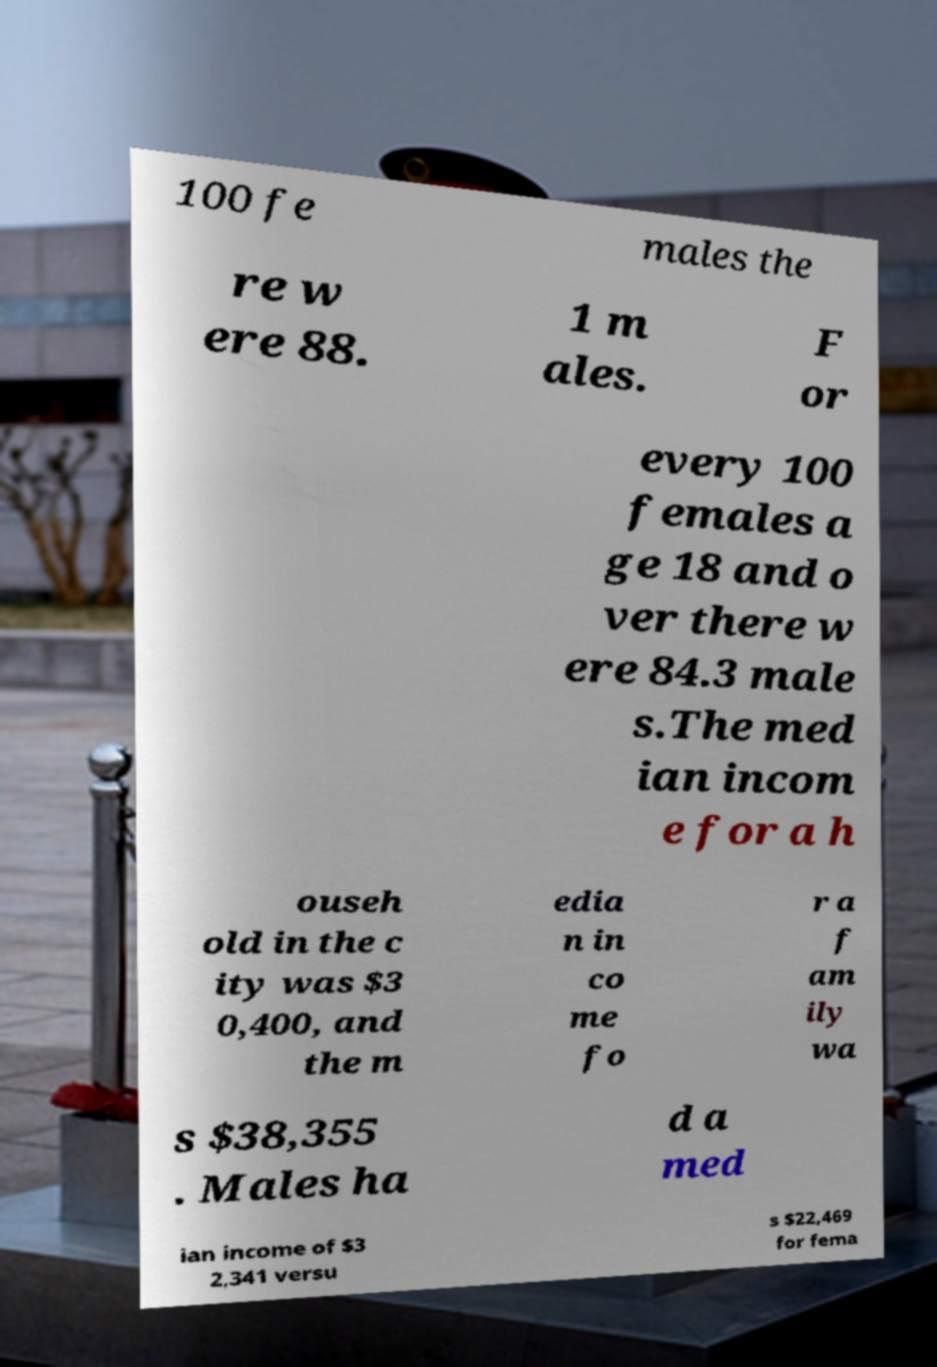Can you read and provide the text displayed in the image?This photo seems to have some interesting text. Can you extract and type it out for me? 100 fe males the re w ere 88. 1 m ales. F or every 100 females a ge 18 and o ver there w ere 84.3 male s.The med ian incom e for a h ouseh old in the c ity was $3 0,400, and the m edia n in co me fo r a f am ily wa s $38,355 . Males ha d a med ian income of $3 2,341 versu s $22,469 for fema 